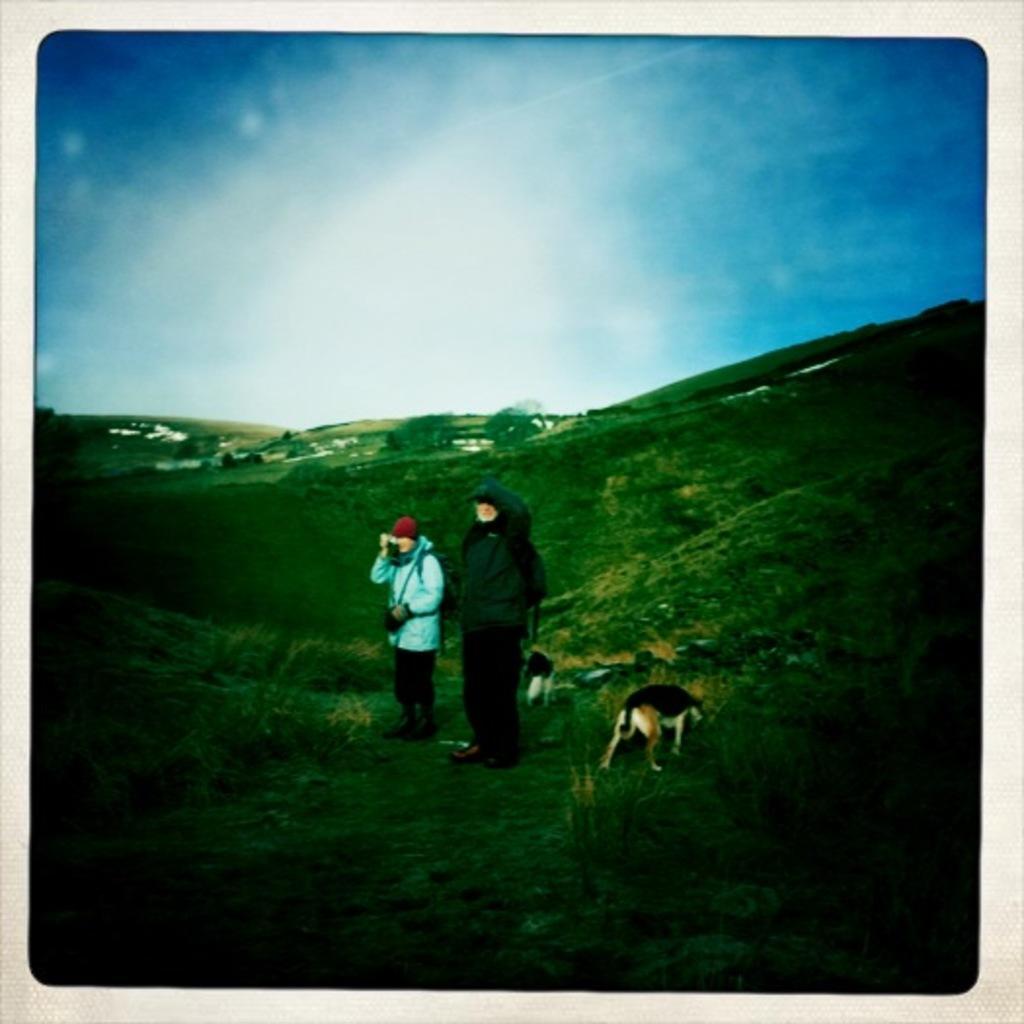Can you describe this image briefly? In this image we can see a photo. There are few hills in the image. There is a grassy land in the image. There is a dog in the image. There are few people in the image. There are few houses in the image. We can see the sky in the image. 